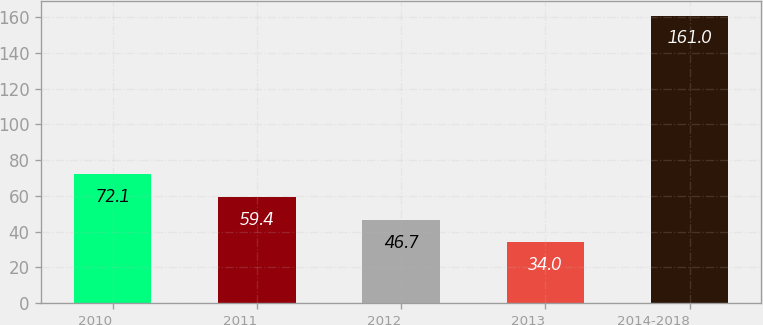<chart> <loc_0><loc_0><loc_500><loc_500><bar_chart><fcel>2010<fcel>2011<fcel>2012<fcel>2013<fcel>2014-2018<nl><fcel>72.1<fcel>59.4<fcel>46.7<fcel>34<fcel>161<nl></chart> 